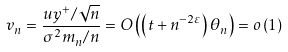Convert formula to latex. <formula><loc_0><loc_0><loc_500><loc_500>v _ { n } = \frac { u y ^ { + } / \sqrt { n } } { \sigma ^ { 2 } m _ { n } / n } = O \left ( \left ( t + n ^ { - 2 \varepsilon } \right ) \theta _ { n } \right ) = o \left ( 1 \right )</formula> 